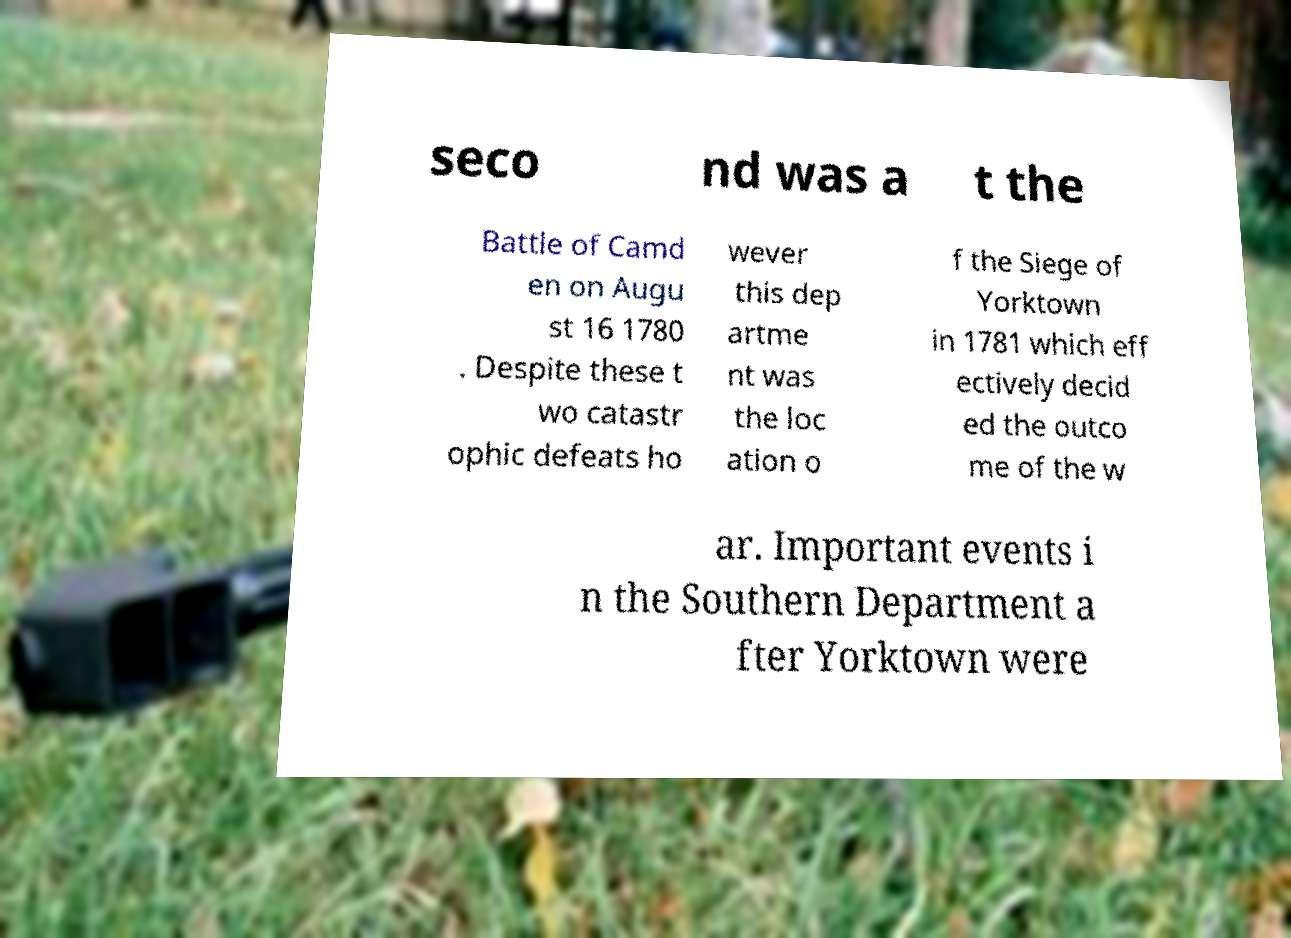Could you extract and type out the text from this image? seco nd was a t the Battle of Camd en on Augu st 16 1780 . Despite these t wo catastr ophic defeats ho wever this dep artme nt was the loc ation o f the Siege of Yorktown in 1781 which eff ectively decid ed the outco me of the w ar. Important events i n the Southern Department a fter Yorktown were 